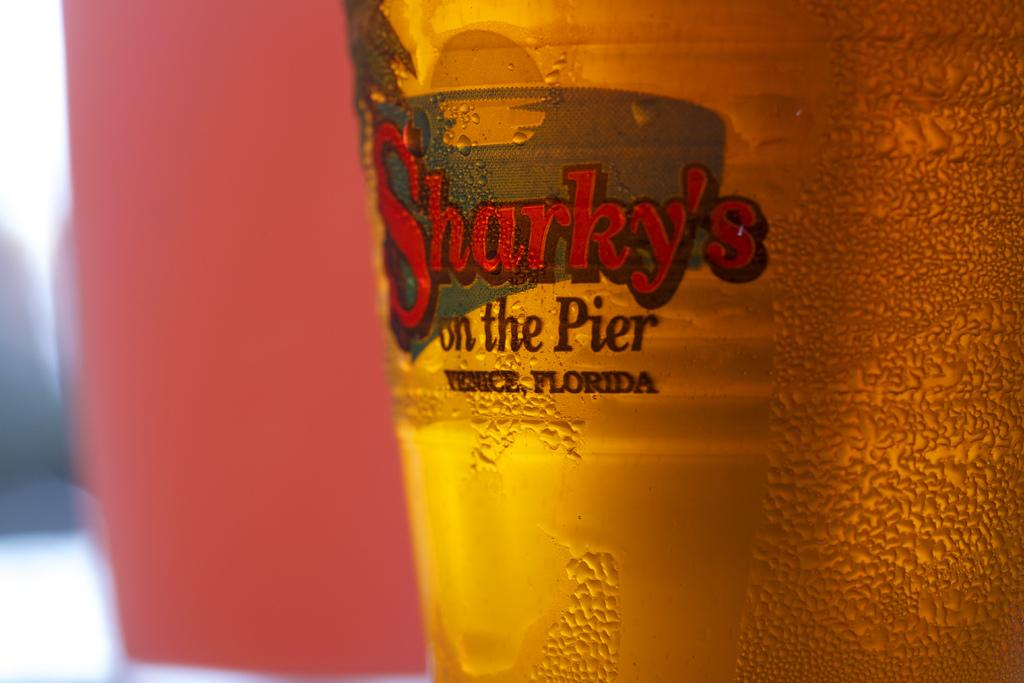<image>
Write a terse but informative summary of the picture. A beer glass that has Sharky's on the Pier on it. 